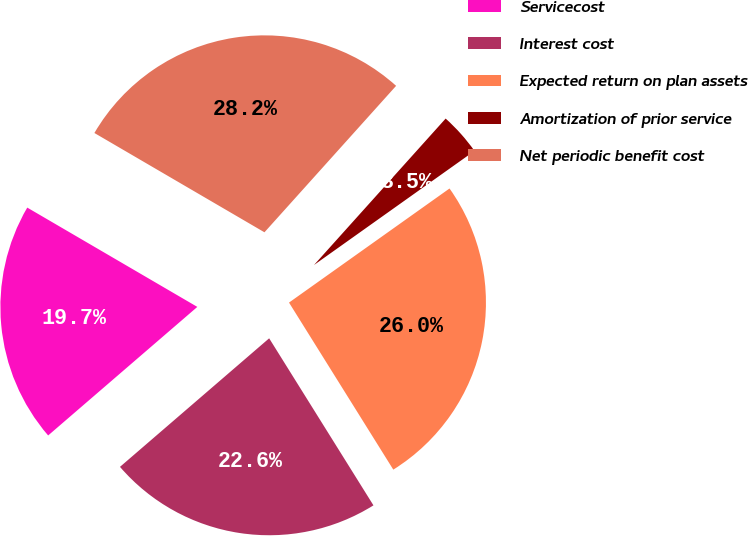Convert chart to OTSL. <chart><loc_0><loc_0><loc_500><loc_500><pie_chart><fcel>Servicecost<fcel>Interest cost<fcel>Expected return on plan assets<fcel>Amortization of prior service<fcel>Net periodic benefit cost<nl><fcel>19.73%<fcel>22.56%<fcel>25.95%<fcel>3.51%<fcel>28.24%<nl></chart> 